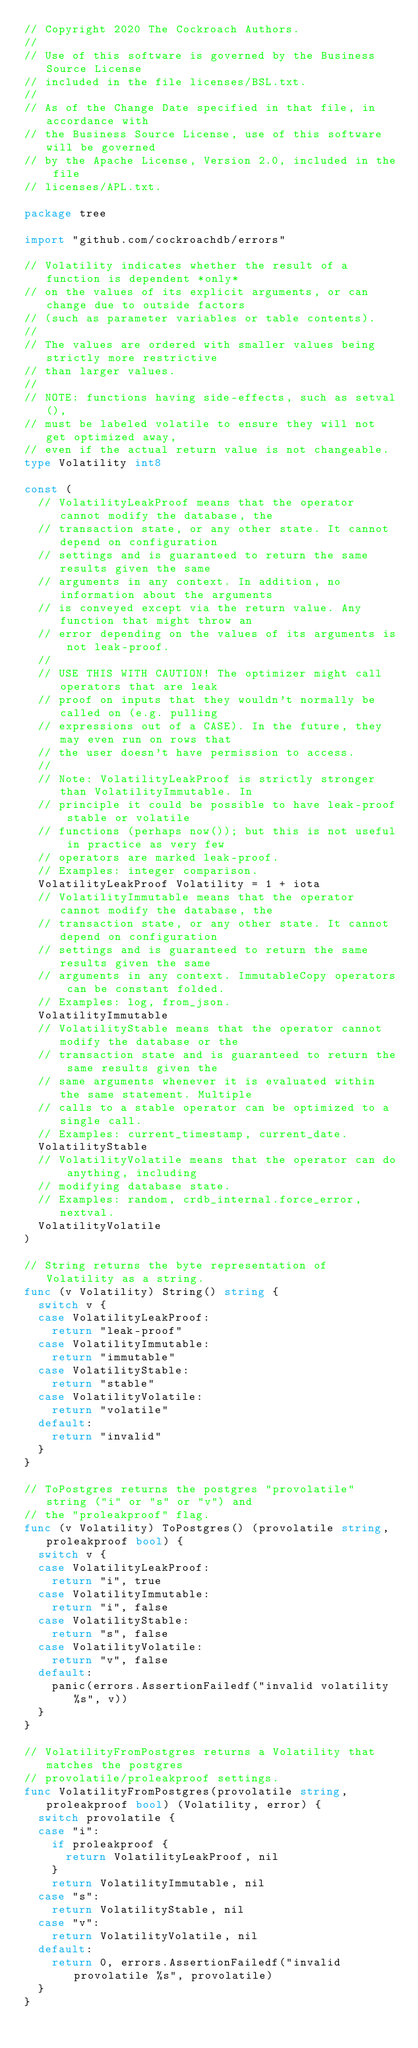Convert code to text. <code><loc_0><loc_0><loc_500><loc_500><_Go_>// Copyright 2020 The Cockroach Authors.
//
// Use of this software is governed by the Business Source License
// included in the file licenses/BSL.txt.
//
// As of the Change Date specified in that file, in accordance with
// the Business Source License, use of this software will be governed
// by the Apache License, Version 2.0, included in the file
// licenses/APL.txt.

package tree

import "github.com/cockroachdb/errors"

// Volatility indicates whether the result of a function is dependent *only*
// on the values of its explicit arguments, or can change due to outside factors
// (such as parameter variables or table contents).
//
// The values are ordered with smaller values being strictly more restrictive
// than larger values.
//
// NOTE: functions having side-effects, such as setval(),
// must be labeled volatile to ensure they will not get optimized away,
// even if the actual return value is not changeable.
type Volatility int8

const (
	// VolatilityLeakProof means that the operator cannot modify the database, the
	// transaction state, or any other state. It cannot depend on configuration
	// settings and is guaranteed to return the same results given the same
	// arguments in any context. In addition, no information about the arguments
	// is conveyed except via the return value. Any function that might throw an
	// error depending on the values of its arguments is not leak-proof.
	//
	// USE THIS WITH CAUTION! The optimizer might call operators that are leak
	// proof on inputs that they wouldn't normally be called on (e.g. pulling
	// expressions out of a CASE). In the future, they may even run on rows that
	// the user doesn't have permission to access.
	//
	// Note: VolatilityLeakProof is strictly stronger than VolatilityImmutable. In
	// principle it could be possible to have leak-proof stable or volatile
	// functions (perhaps now()); but this is not useful in practice as very few
	// operators are marked leak-proof.
	// Examples: integer comparison.
	VolatilityLeakProof Volatility = 1 + iota
	// VolatilityImmutable means that the operator cannot modify the database, the
	// transaction state, or any other state. It cannot depend on configuration
	// settings and is guaranteed to return the same results given the same
	// arguments in any context. ImmutableCopy operators can be constant folded.
	// Examples: log, from_json.
	VolatilityImmutable
	// VolatilityStable means that the operator cannot modify the database or the
	// transaction state and is guaranteed to return the same results given the
	// same arguments whenever it is evaluated within the same statement. Multiple
	// calls to a stable operator can be optimized to a single call.
	// Examples: current_timestamp, current_date.
	VolatilityStable
	// VolatilityVolatile means that the operator can do anything, including
	// modifying database state.
	// Examples: random, crdb_internal.force_error, nextval.
	VolatilityVolatile
)

// String returns the byte representation of Volatility as a string.
func (v Volatility) String() string {
	switch v {
	case VolatilityLeakProof:
		return "leak-proof"
	case VolatilityImmutable:
		return "immutable"
	case VolatilityStable:
		return "stable"
	case VolatilityVolatile:
		return "volatile"
	default:
		return "invalid"
	}
}

// ToPostgres returns the postgres "provolatile" string ("i" or "s" or "v") and
// the "proleakproof" flag.
func (v Volatility) ToPostgres() (provolatile string, proleakproof bool) {
	switch v {
	case VolatilityLeakProof:
		return "i", true
	case VolatilityImmutable:
		return "i", false
	case VolatilityStable:
		return "s", false
	case VolatilityVolatile:
		return "v", false
	default:
		panic(errors.AssertionFailedf("invalid volatility %s", v))
	}
}

// VolatilityFromPostgres returns a Volatility that matches the postgres
// provolatile/proleakproof settings.
func VolatilityFromPostgres(provolatile string, proleakproof bool) (Volatility, error) {
	switch provolatile {
	case "i":
		if proleakproof {
			return VolatilityLeakProof, nil
		}
		return VolatilityImmutable, nil
	case "s":
		return VolatilityStable, nil
	case "v":
		return VolatilityVolatile, nil
	default:
		return 0, errors.AssertionFailedf("invalid provolatile %s", provolatile)
	}
}
</code> 